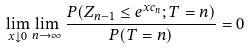Convert formula to latex. <formula><loc_0><loc_0><loc_500><loc_500>\lim _ { x \downarrow 0 } \lim _ { n \rightarrow \infty } \frac { P ( Z _ { n - 1 } \leq e ^ { x c _ { n } } ; T = n ) } { P ( T = n ) } = 0</formula> 